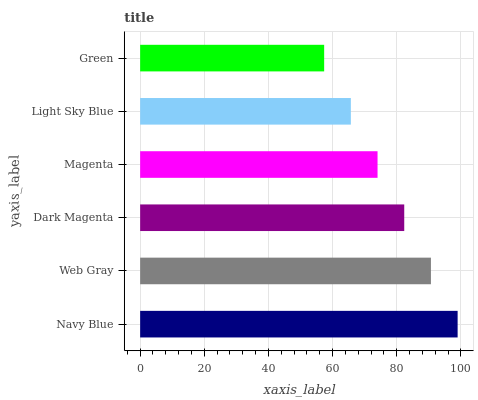Is Green the minimum?
Answer yes or no. Yes. Is Navy Blue the maximum?
Answer yes or no. Yes. Is Web Gray the minimum?
Answer yes or no. No. Is Web Gray the maximum?
Answer yes or no. No. Is Navy Blue greater than Web Gray?
Answer yes or no. Yes. Is Web Gray less than Navy Blue?
Answer yes or no. Yes. Is Web Gray greater than Navy Blue?
Answer yes or no. No. Is Navy Blue less than Web Gray?
Answer yes or no. No. Is Dark Magenta the high median?
Answer yes or no. Yes. Is Magenta the low median?
Answer yes or no. Yes. Is Navy Blue the high median?
Answer yes or no. No. Is Navy Blue the low median?
Answer yes or no. No. 